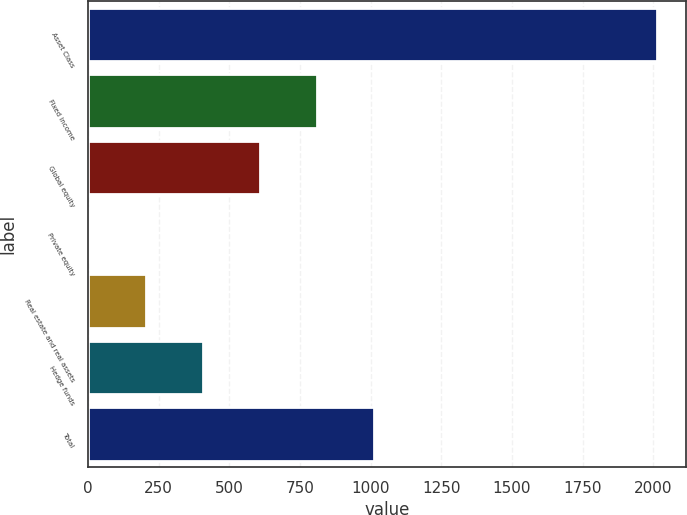<chart> <loc_0><loc_0><loc_500><loc_500><bar_chart><fcel>Asset Class<fcel>Fixed income<fcel>Global equity<fcel>Private equity<fcel>Real estate and real assets<fcel>Hedge funds<fcel>Total<nl><fcel>2015<fcel>809<fcel>608<fcel>5<fcel>206<fcel>407<fcel>1010<nl></chart> 